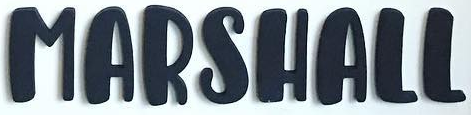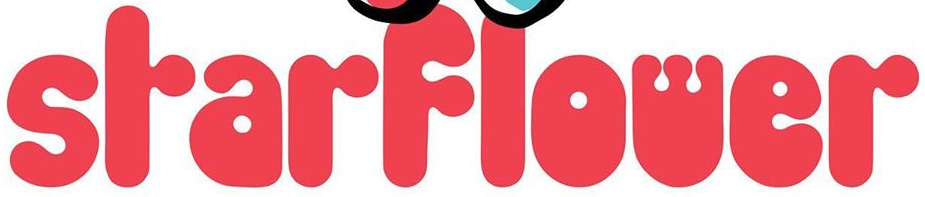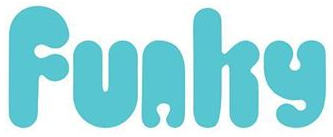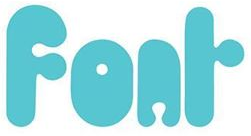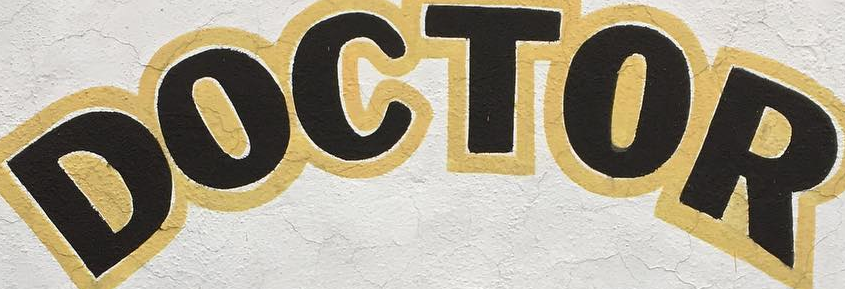What words can you see in these images in sequence, separated by a semicolon? MARSHALL; SrarFlower; Funhy; Fonr; DOCTOR 